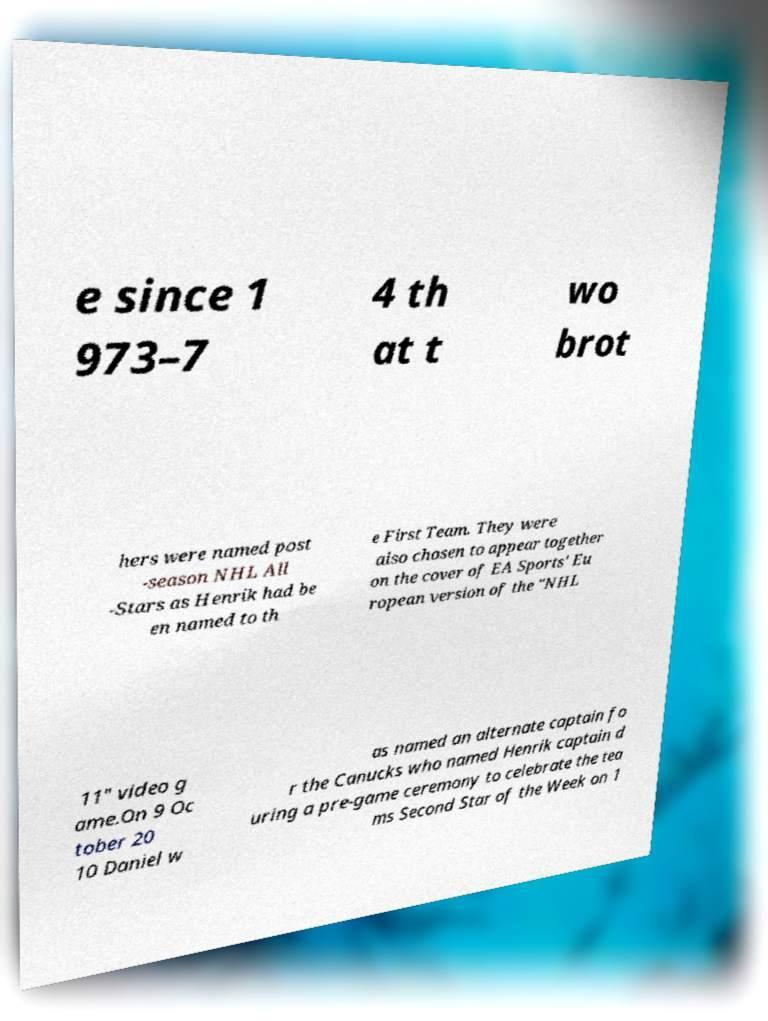Can you accurately transcribe the text from the provided image for me? e since 1 973–7 4 th at t wo brot hers were named post -season NHL All -Stars as Henrik had be en named to th e First Team. They were also chosen to appear together on the cover of EA Sports' Eu ropean version of the "NHL 11" video g ame.On 9 Oc tober 20 10 Daniel w as named an alternate captain fo r the Canucks who named Henrik captain d uring a pre-game ceremony to celebrate the tea ms Second Star of the Week on 1 